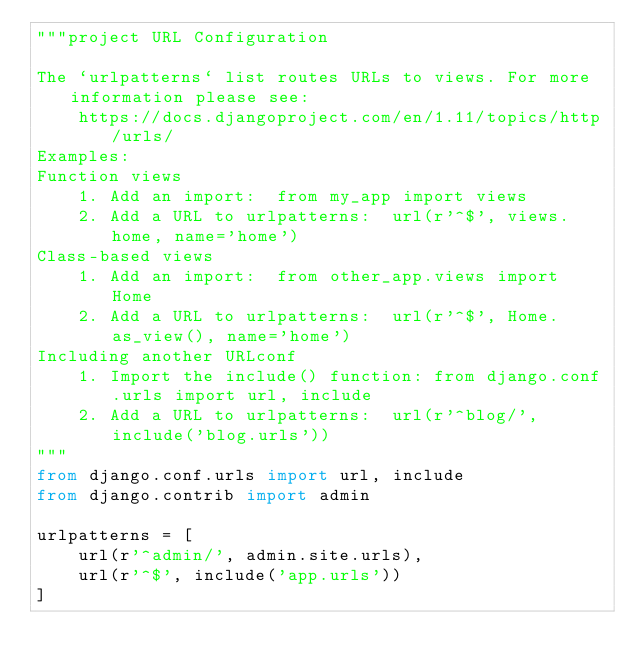<code> <loc_0><loc_0><loc_500><loc_500><_Python_>"""project URL Configuration

The `urlpatterns` list routes URLs to views. For more information please see:
    https://docs.djangoproject.com/en/1.11/topics/http/urls/
Examples:
Function views
    1. Add an import:  from my_app import views
    2. Add a URL to urlpatterns:  url(r'^$', views.home, name='home')
Class-based views
    1. Add an import:  from other_app.views import Home
    2. Add a URL to urlpatterns:  url(r'^$', Home.as_view(), name='home')
Including another URLconf
    1. Import the include() function: from django.conf.urls import url, include
    2. Add a URL to urlpatterns:  url(r'^blog/', include('blog.urls'))
"""
from django.conf.urls import url, include
from django.contrib import admin

urlpatterns = [
    url(r'^admin/', admin.site.urls),
    url(r'^$', include('app.urls'))
]
</code> 